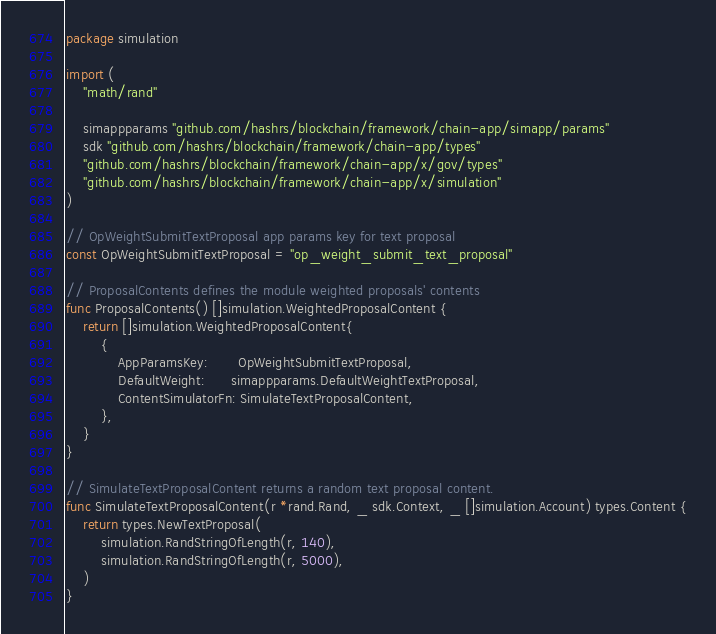Convert code to text. <code><loc_0><loc_0><loc_500><loc_500><_Go_>package simulation

import (
	"math/rand"

	simappparams "github.com/hashrs/blockchain/framework/chain-app/simapp/params"
	sdk "github.com/hashrs/blockchain/framework/chain-app/types"
	"github.com/hashrs/blockchain/framework/chain-app/x/gov/types"
	"github.com/hashrs/blockchain/framework/chain-app/x/simulation"
)

// OpWeightSubmitTextProposal app params key for text proposal
const OpWeightSubmitTextProposal = "op_weight_submit_text_proposal"

// ProposalContents defines the module weighted proposals' contents
func ProposalContents() []simulation.WeightedProposalContent {
	return []simulation.WeightedProposalContent{
		{
			AppParamsKey:       OpWeightSubmitTextProposal,
			DefaultWeight:      simappparams.DefaultWeightTextProposal,
			ContentSimulatorFn: SimulateTextProposalContent,
		},
	}
}

// SimulateTextProposalContent returns a random text proposal content.
func SimulateTextProposalContent(r *rand.Rand, _ sdk.Context, _ []simulation.Account) types.Content {
	return types.NewTextProposal(
		simulation.RandStringOfLength(r, 140),
		simulation.RandStringOfLength(r, 5000),
	)
}
</code> 